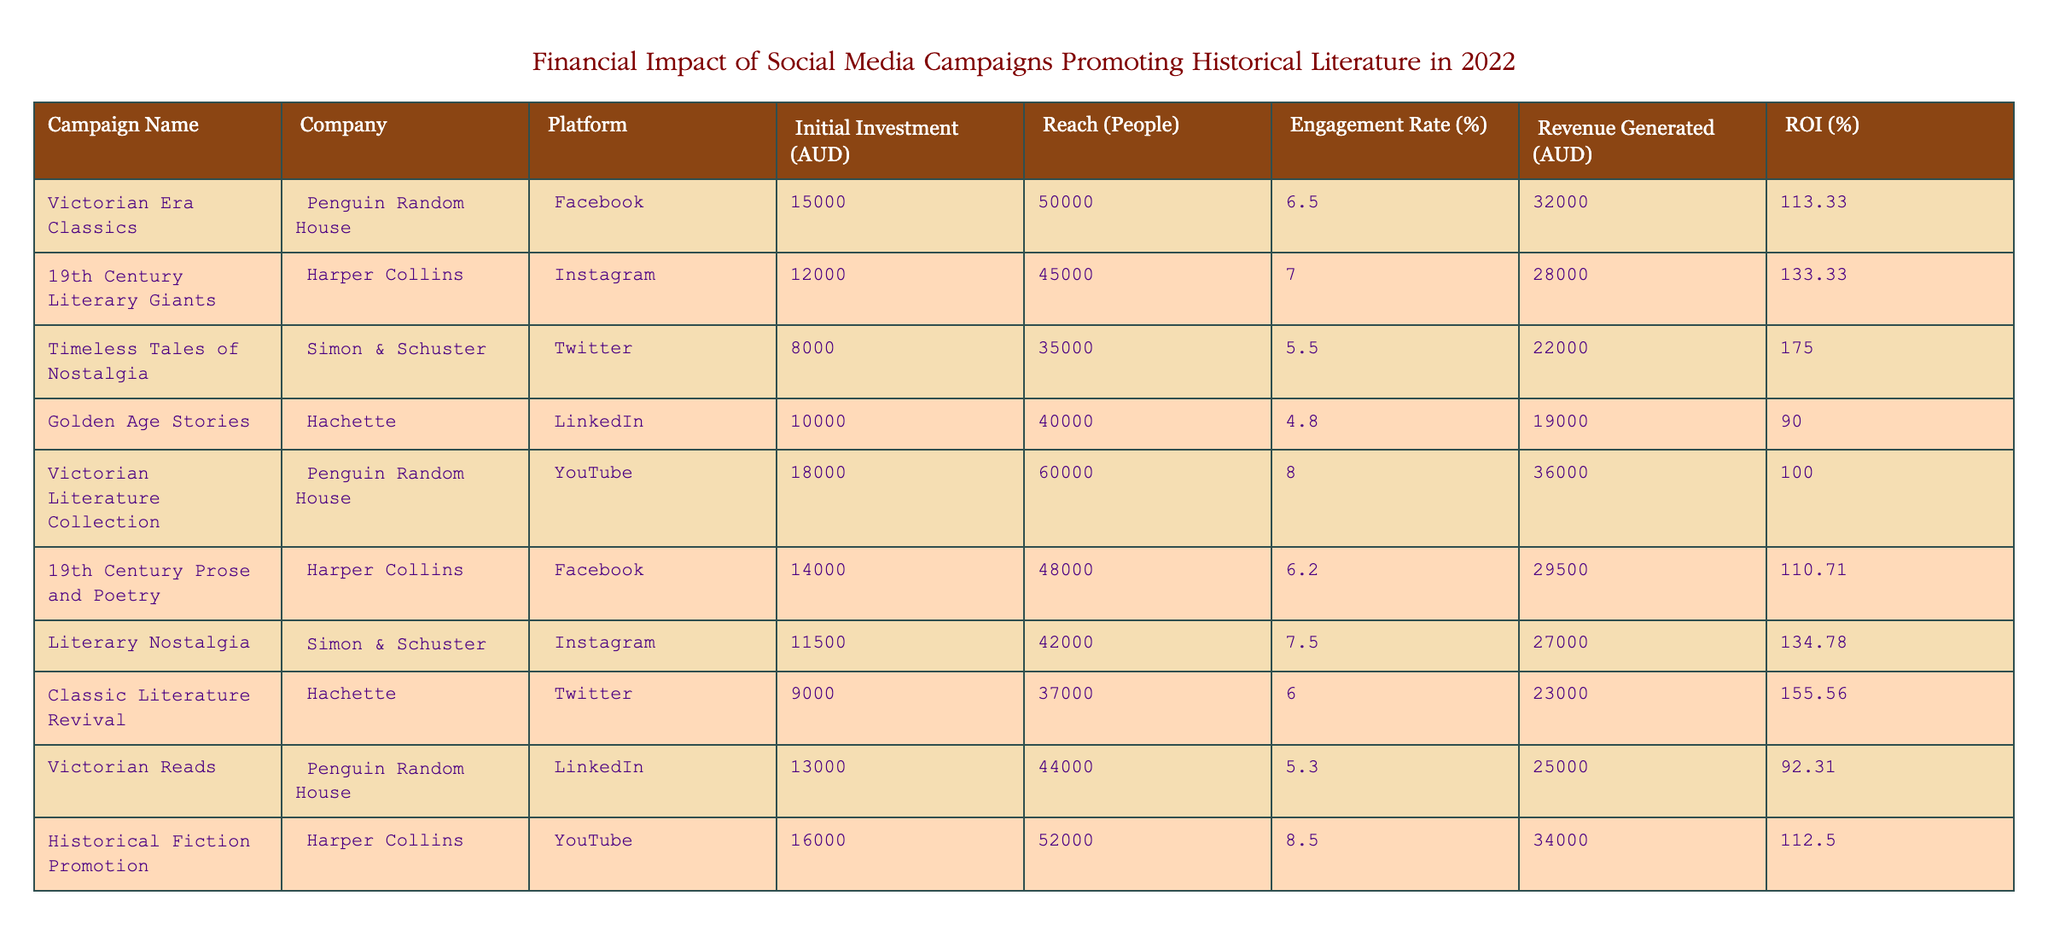What is the total revenue generated by all campaigns? To find the total revenue, we need to sum the revenue generated by each campaign from the table. The values are: 32000 + 28000 + 22000 + 19000 + 36000 + 29500 + 27000 + 23000 + 25000 + 34000. Adding these gives us a total of 219500 AUD.
Answer: 219500 Which campaign had the highest return on investment (ROI)? Looking at the ROI column, we see the values are: 113.33, 133.33, 175.00, 90.00, 100.00, 110.71, 134.78, 155.56, 92.31, and 112.50. The highest value is 175.00 associated with the campaign "Timeless Tales of Nostalgia."
Answer: Timeless Tales of Nostalgia Was "Victorian Reads" more effective in terms of engagement rate compared to "Golden Age Stories"? "Victorian Reads" has an engagement rate of 5.3% while "Golden Age Stories" has a rate of 4.8%. Since 5.3% is greater than 4.8%, "Victorian Reads" was indeed more effective.
Answer: Yes What was the average initial investment across all campaigns? To calculate the average initial investment, first, sum the initial investments: 15000 + 12000 + 8000 + 10000 + 18000 + 14000 + 11500 + 9000 + 13000 + 16000 = 115500. Then, divide this sum by the number of campaigns (10): 115500 / 10 = 11550.
Answer: 11550 Is the engagement rate of "Historical Fiction Promotion" higher than the average engagement rate of all campaigns? First, find the average engagement rate. The engagement rates are 6.5, 7.0, 5.5, 4.8, 8.0, 6.2, 7.5, 6.0, 5.3, and 8.5. The sum is 60.3 and the average is 60.3 / 10 = 6.03. The engagement rate for "Historical Fiction Promotion" is 8.5%, which is higher than 6.03%.
Answer: Yes Which company had the least amount invested in their campaign? The initial investments are: 15000, 12000, 8000, 10000, 18000, 14000, 11500, 9000, 13000, and 16000. The smallest value is 8000, which belongs to Simon & Schuster for the "Timeless Tales of Nostalgia" campaign.
Answer: Simon & Schuster 